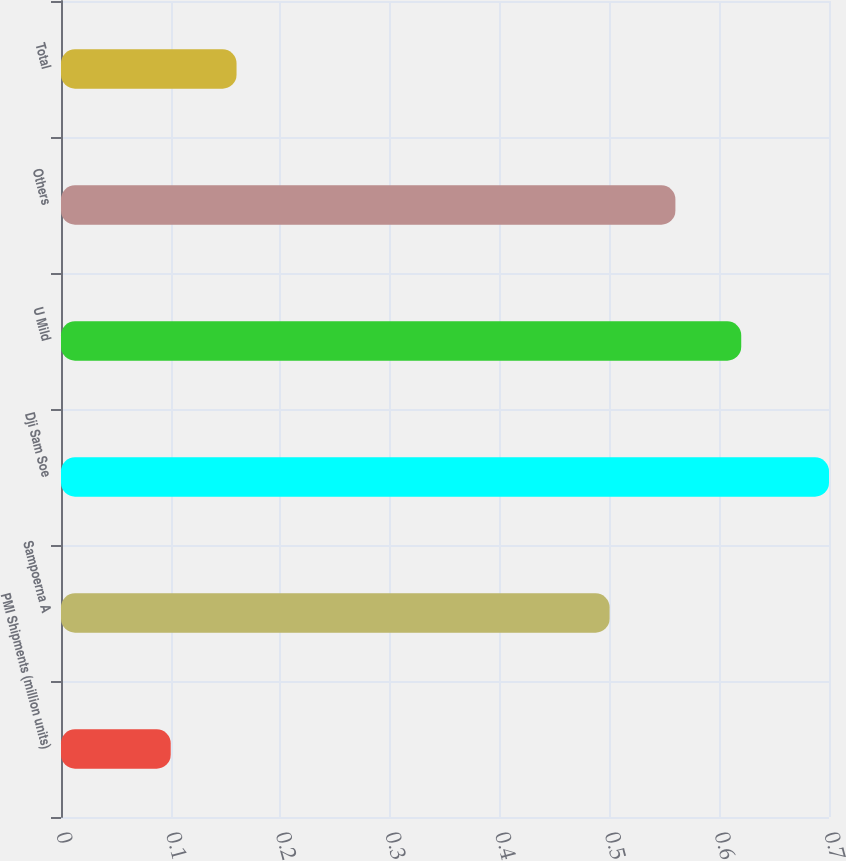Convert chart to OTSL. <chart><loc_0><loc_0><loc_500><loc_500><bar_chart><fcel>PMI Shipments (million units)<fcel>Sampoerna A<fcel>Dji Sam Soe<fcel>U Mild<fcel>Others<fcel>Total<nl><fcel>0.1<fcel>0.5<fcel>0.7<fcel>0.62<fcel>0.56<fcel>0.16<nl></chart> 